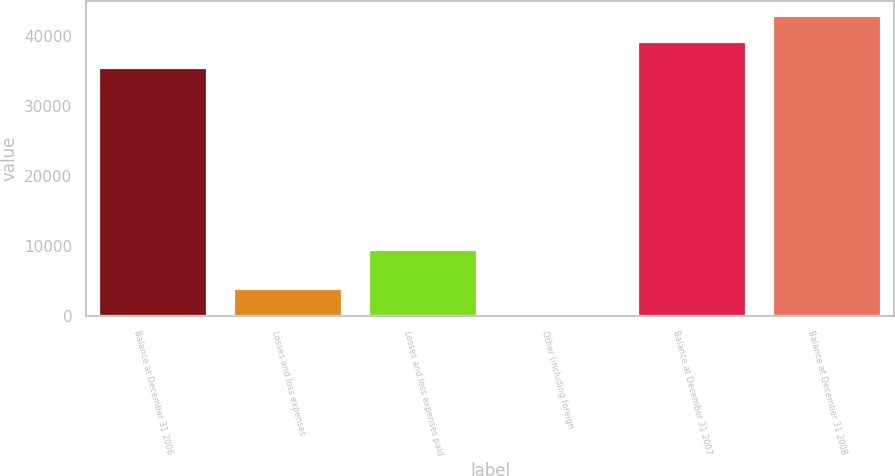Convert chart to OTSL. <chart><loc_0><loc_0><loc_500><loc_500><bar_chart><fcel>Balance at December 31 2006<fcel>Losses and loss expenses<fcel>Losses and loss expenses paid<fcel>Other (including foreign<fcel>Balance at December 31 2007<fcel>Balance at December 31 2008<nl><fcel>35517<fcel>3969.6<fcel>9516<fcel>280<fcel>39206.6<fcel>42896.2<nl></chart> 